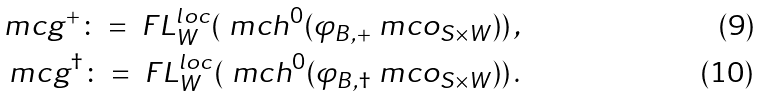Convert formula to latex. <formula><loc_0><loc_0><loc_500><loc_500>\ m c g ^ { + } \colon = \ F L ^ { l o c } _ { W } ( \ m c h ^ { 0 } ( \varphi _ { B , + } \ m c o _ { S \times W } ) ) \, , \\ \ m c g ^ { \dag } \colon = \ F L ^ { l o c } _ { W } ( \ m c h ^ { 0 } ( \varphi _ { B , \dag } \ m c o _ { S \times W } ) ) \, .</formula> 